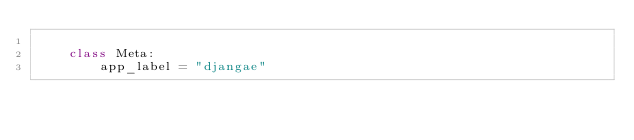Convert code to text. <code><loc_0><loc_0><loc_500><loc_500><_Python_>
    class Meta:
        app_label = "djangae"
</code> 